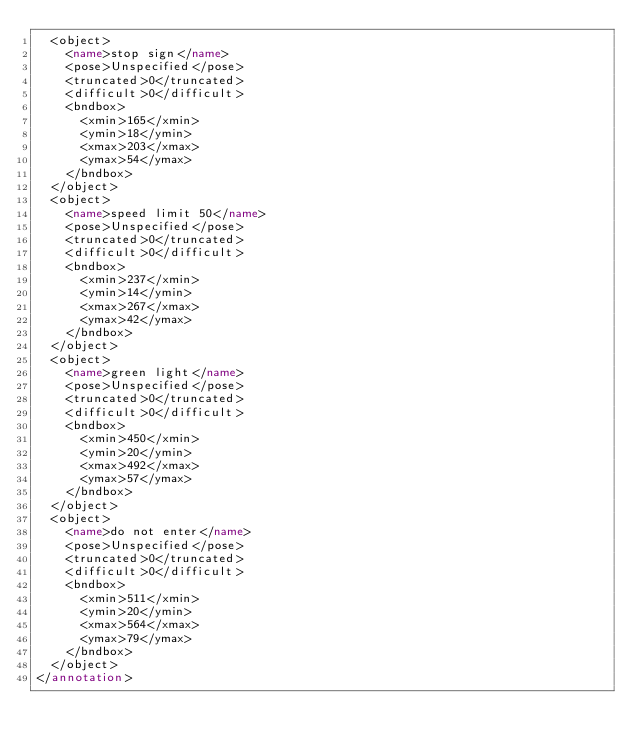Convert code to text. <code><loc_0><loc_0><loc_500><loc_500><_XML_>	<object>
		<name>stop sign</name>
		<pose>Unspecified</pose>
		<truncated>0</truncated>
		<difficult>0</difficult>
		<bndbox>
			<xmin>165</xmin>
			<ymin>18</ymin>
			<xmax>203</xmax>
			<ymax>54</ymax>
		</bndbox>
	</object>
	<object>
		<name>speed limit 50</name>
		<pose>Unspecified</pose>
		<truncated>0</truncated>
		<difficult>0</difficult>
		<bndbox>
			<xmin>237</xmin>
			<ymin>14</ymin>
			<xmax>267</xmax>
			<ymax>42</ymax>
		</bndbox>
	</object>
	<object>
		<name>green light</name>
		<pose>Unspecified</pose>
		<truncated>0</truncated>
		<difficult>0</difficult>
		<bndbox>
			<xmin>450</xmin>
			<ymin>20</ymin>
			<xmax>492</xmax>
			<ymax>57</ymax>
		</bndbox>
	</object>
	<object>
		<name>do not enter</name>
		<pose>Unspecified</pose>
		<truncated>0</truncated>
		<difficult>0</difficult>
		<bndbox>
			<xmin>511</xmin>
			<ymin>20</ymin>
			<xmax>564</xmax>
			<ymax>79</ymax>
		</bndbox>
	</object>
</annotation>
</code> 